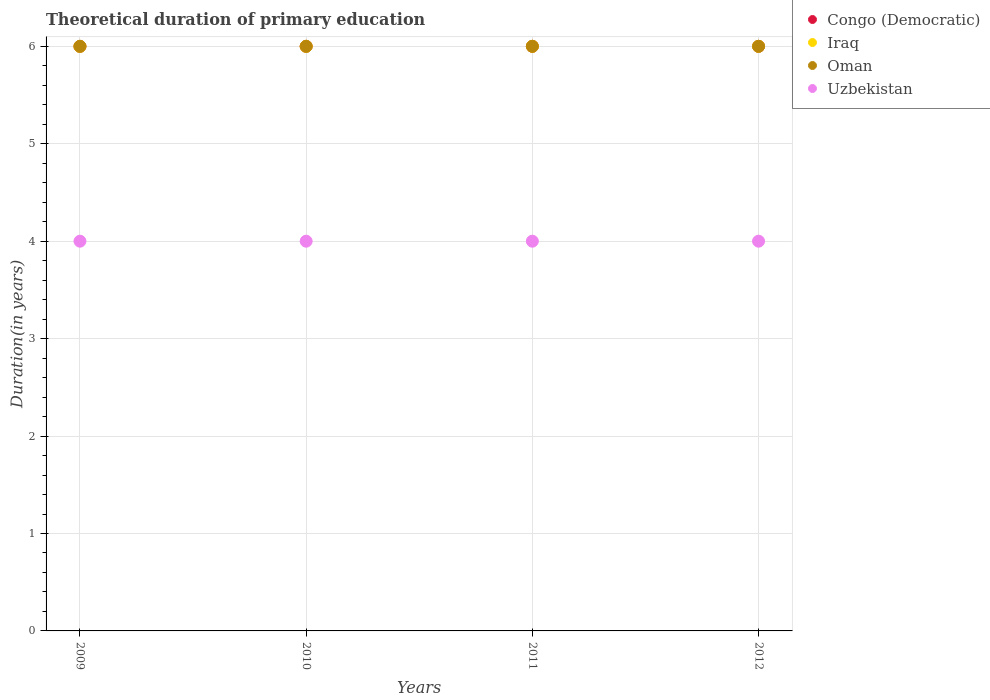Is the number of dotlines equal to the number of legend labels?
Your response must be concise. Yes. What is the total theoretical duration of primary education in Uzbekistan in 2009?
Offer a terse response. 4. Across all years, what is the maximum total theoretical duration of primary education in Congo (Democratic)?
Provide a short and direct response. 6. In which year was the total theoretical duration of primary education in Oman minimum?
Provide a short and direct response. 2009. What is the total total theoretical duration of primary education in Uzbekistan in the graph?
Your answer should be very brief. 16. What is the difference between the total theoretical duration of primary education in Congo (Democratic) in 2011 and that in 2012?
Make the answer very short. 0. In the year 2012, what is the difference between the total theoretical duration of primary education in Oman and total theoretical duration of primary education in Uzbekistan?
Provide a succinct answer. 2. Is the total theoretical duration of primary education in Iraq in 2010 less than that in 2012?
Your response must be concise. No. What is the difference between the highest and the second highest total theoretical duration of primary education in Congo (Democratic)?
Give a very brief answer. 0. In how many years, is the total theoretical duration of primary education in Iraq greater than the average total theoretical duration of primary education in Iraq taken over all years?
Offer a terse response. 0. Is the sum of the total theoretical duration of primary education in Uzbekistan in 2011 and 2012 greater than the maximum total theoretical duration of primary education in Congo (Democratic) across all years?
Offer a very short reply. Yes. How many years are there in the graph?
Provide a succinct answer. 4. Are the values on the major ticks of Y-axis written in scientific E-notation?
Give a very brief answer. No. Does the graph contain grids?
Provide a succinct answer. Yes. What is the title of the graph?
Provide a short and direct response. Theoretical duration of primary education. Does "Afghanistan" appear as one of the legend labels in the graph?
Give a very brief answer. No. What is the label or title of the Y-axis?
Give a very brief answer. Duration(in years). What is the Duration(in years) of Congo (Democratic) in 2009?
Make the answer very short. 6. What is the Duration(in years) in Iraq in 2009?
Your response must be concise. 6. What is the Duration(in years) in Congo (Democratic) in 2010?
Keep it short and to the point. 6. What is the Duration(in years) of Oman in 2010?
Give a very brief answer. 6. What is the Duration(in years) in Iraq in 2011?
Your answer should be compact. 6. What is the Duration(in years) of Oman in 2011?
Your answer should be compact. 6. What is the Duration(in years) of Congo (Democratic) in 2012?
Offer a very short reply. 6. Across all years, what is the maximum Duration(in years) of Uzbekistan?
Offer a very short reply. 4. Across all years, what is the minimum Duration(in years) of Uzbekistan?
Your answer should be very brief. 4. What is the total Duration(in years) of Uzbekistan in the graph?
Provide a short and direct response. 16. What is the difference between the Duration(in years) in Congo (Democratic) in 2009 and that in 2011?
Your answer should be compact. 0. What is the difference between the Duration(in years) of Iraq in 2009 and that in 2012?
Keep it short and to the point. 0. What is the difference between the Duration(in years) in Uzbekistan in 2009 and that in 2012?
Provide a succinct answer. 0. What is the difference between the Duration(in years) in Uzbekistan in 2010 and that in 2012?
Your response must be concise. 0. What is the difference between the Duration(in years) of Congo (Democratic) in 2011 and that in 2012?
Give a very brief answer. 0. What is the difference between the Duration(in years) of Oman in 2011 and that in 2012?
Provide a short and direct response. 0. What is the difference between the Duration(in years) in Congo (Democratic) in 2009 and the Duration(in years) in Oman in 2010?
Provide a succinct answer. 0. What is the difference between the Duration(in years) of Congo (Democratic) in 2009 and the Duration(in years) of Uzbekistan in 2010?
Provide a succinct answer. 2. What is the difference between the Duration(in years) of Iraq in 2009 and the Duration(in years) of Oman in 2010?
Make the answer very short. 0. What is the difference between the Duration(in years) in Oman in 2009 and the Duration(in years) in Uzbekistan in 2010?
Provide a succinct answer. 2. What is the difference between the Duration(in years) of Congo (Democratic) in 2009 and the Duration(in years) of Iraq in 2011?
Ensure brevity in your answer.  0. What is the difference between the Duration(in years) in Congo (Democratic) in 2009 and the Duration(in years) in Oman in 2011?
Your response must be concise. 0. What is the difference between the Duration(in years) of Congo (Democratic) in 2009 and the Duration(in years) of Uzbekistan in 2011?
Your answer should be compact. 2. What is the difference between the Duration(in years) in Oman in 2009 and the Duration(in years) in Uzbekistan in 2011?
Offer a terse response. 2. What is the difference between the Duration(in years) in Iraq in 2009 and the Duration(in years) in Uzbekistan in 2012?
Offer a very short reply. 2. What is the difference between the Duration(in years) of Oman in 2009 and the Duration(in years) of Uzbekistan in 2012?
Offer a terse response. 2. What is the difference between the Duration(in years) of Oman in 2010 and the Duration(in years) of Uzbekistan in 2011?
Your answer should be compact. 2. What is the difference between the Duration(in years) in Congo (Democratic) in 2010 and the Duration(in years) in Oman in 2012?
Provide a short and direct response. 0. What is the difference between the Duration(in years) in Iraq in 2010 and the Duration(in years) in Oman in 2012?
Ensure brevity in your answer.  0. What is the difference between the Duration(in years) of Iraq in 2010 and the Duration(in years) of Uzbekistan in 2012?
Offer a very short reply. 2. What is the difference between the Duration(in years) in Oman in 2010 and the Duration(in years) in Uzbekistan in 2012?
Offer a terse response. 2. What is the difference between the Duration(in years) in Congo (Democratic) in 2011 and the Duration(in years) in Iraq in 2012?
Your response must be concise. 0. What is the difference between the Duration(in years) in Iraq in 2011 and the Duration(in years) in Oman in 2012?
Make the answer very short. 0. What is the difference between the Duration(in years) in Iraq in 2011 and the Duration(in years) in Uzbekistan in 2012?
Your answer should be compact. 2. What is the average Duration(in years) of Oman per year?
Provide a succinct answer. 6. In the year 2009, what is the difference between the Duration(in years) in Iraq and Duration(in years) in Oman?
Offer a terse response. 0. In the year 2009, what is the difference between the Duration(in years) in Iraq and Duration(in years) in Uzbekistan?
Provide a succinct answer. 2. In the year 2009, what is the difference between the Duration(in years) of Oman and Duration(in years) of Uzbekistan?
Offer a terse response. 2. In the year 2010, what is the difference between the Duration(in years) in Congo (Democratic) and Duration(in years) in Iraq?
Provide a short and direct response. 0. In the year 2010, what is the difference between the Duration(in years) of Congo (Democratic) and Duration(in years) of Uzbekistan?
Your answer should be compact. 2. In the year 2010, what is the difference between the Duration(in years) in Iraq and Duration(in years) in Uzbekistan?
Ensure brevity in your answer.  2. In the year 2011, what is the difference between the Duration(in years) in Congo (Democratic) and Duration(in years) in Iraq?
Provide a succinct answer. 0. In the year 2011, what is the difference between the Duration(in years) of Congo (Democratic) and Duration(in years) of Oman?
Offer a terse response. 0. In the year 2011, what is the difference between the Duration(in years) of Iraq and Duration(in years) of Oman?
Make the answer very short. 0. In the year 2011, what is the difference between the Duration(in years) in Oman and Duration(in years) in Uzbekistan?
Your response must be concise. 2. In the year 2012, what is the difference between the Duration(in years) in Congo (Democratic) and Duration(in years) in Oman?
Provide a short and direct response. 0. What is the ratio of the Duration(in years) in Iraq in 2009 to that in 2010?
Keep it short and to the point. 1. What is the ratio of the Duration(in years) in Oman in 2009 to that in 2010?
Your response must be concise. 1. What is the ratio of the Duration(in years) of Uzbekistan in 2009 to that in 2010?
Your response must be concise. 1. What is the ratio of the Duration(in years) of Uzbekistan in 2009 to that in 2011?
Provide a succinct answer. 1. What is the ratio of the Duration(in years) of Congo (Democratic) in 2009 to that in 2012?
Make the answer very short. 1. What is the ratio of the Duration(in years) of Iraq in 2009 to that in 2012?
Provide a short and direct response. 1. What is the ratio of the Duration(in years) in Uzbekistan in 2009 to that in 2012?
Offer a very short reply. 1. What is the ratio of the Duration(in years) in Oman in 2010 to that in 2011?
Offer a very short reply. 1. What is the ratio of the Duration(in years) in Uzbekistan in 2011 to that in 2012?
Offer a very short reply. 1. What is the difference between the highest and the lowest Duration(in years) of Congo (Democratic)?
Give a very brief answer. 0. What is the difference between the highest and the lowest Duration(in years) in Oman?
Offer a terse response. 0. What is the difference between the highest and the lowest Duration(in years) of Uzbekistan?
Provide a short and direct response. 0. 